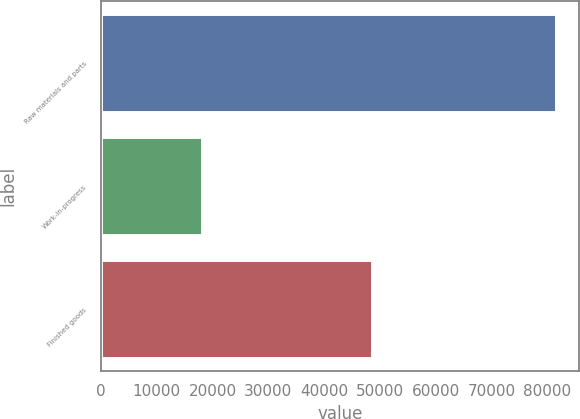Convert chart. <chart><loc_0><loc_0><loc_500><loc_500><bar_chart><fcel>Raw materials and parts<fcel>Work-in-progress<fcel>Finished goods<nl><fcel>81596<fcel>18163<fcel>48613<nl></chart> 